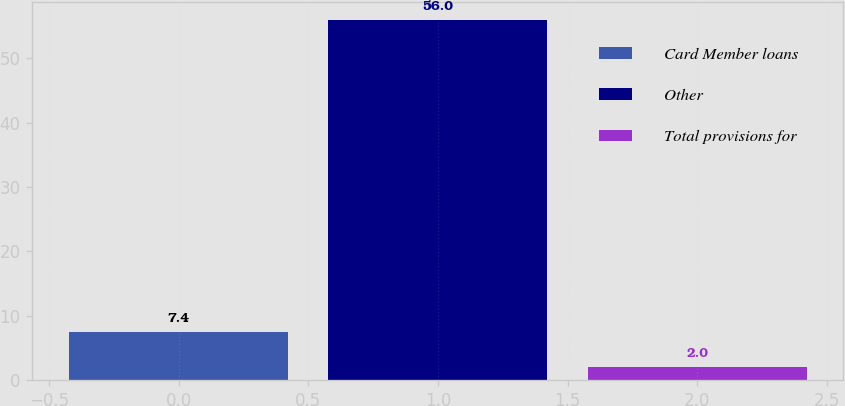<chart> <loc_0><loc_0><loc_500><loc_500><bar_chart><fcel>Card Member loans<fcel>Other<fcel>Total provisions for<nl><fcel>7.4<fcel>56<fcel>2<nl></chart> 